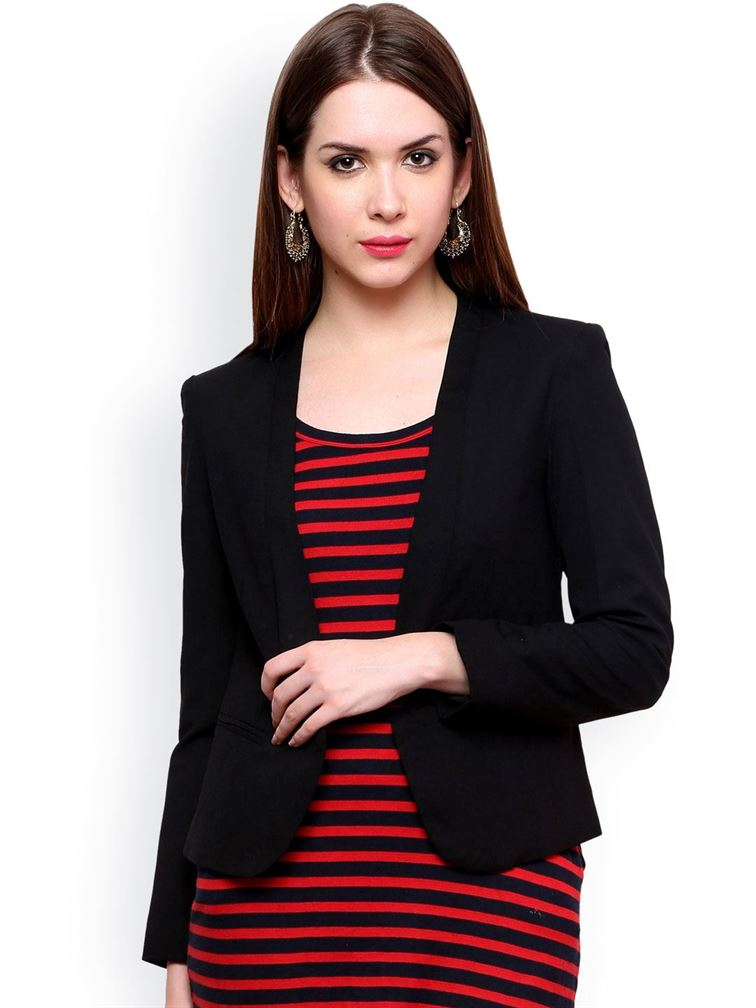Describe the design elements of her outfit. The outfit consists of a stylish black blazer paired with a red and black striped dress. The black blazer adds a formal touch, with its tailored fit accentuating a sleek and professional silhouette. Underneath, the red and black horizontally striped dress provides a striking contrast, adding vibrance and personality. This combination of classic black with bold stripes creates a balanced look that is both professional and eye-catching. Can you describe a scenario where this outfit would be perfectly appropriate? This outfit would be perfectly appropriate for a business conference where the woman might need to present herself as professional yet approachable. The black blazer conveys authority and seriousness, while the striped dress offers a touch of creativity and individuality. Together, they make for an ideal ensemble for networking events, business presentations, or even after-work social gatherings where maintaining a polished image is important. Imagine if she walked into a room full of historical artifacts from the Victorian era. How would her modern outfit contrast with the surroundings? Walking into a room full of Victorian-era artifacts, her modern outfit would present a striking contrast to the opulence and intricacy typical of that period. The clean lines of her black blazer and the bold simplicity of her striped dress would stand out against the elaborate furniture, delicate lacework, and richly patterned textiles of the Victorian age. This juxtaposition emphasizes the evolution of fashion from the ornate to the streamlined, highlighting the functionality and minimalist elegance of contemporary styles compared to the grandeur and decorative excess of the past. 